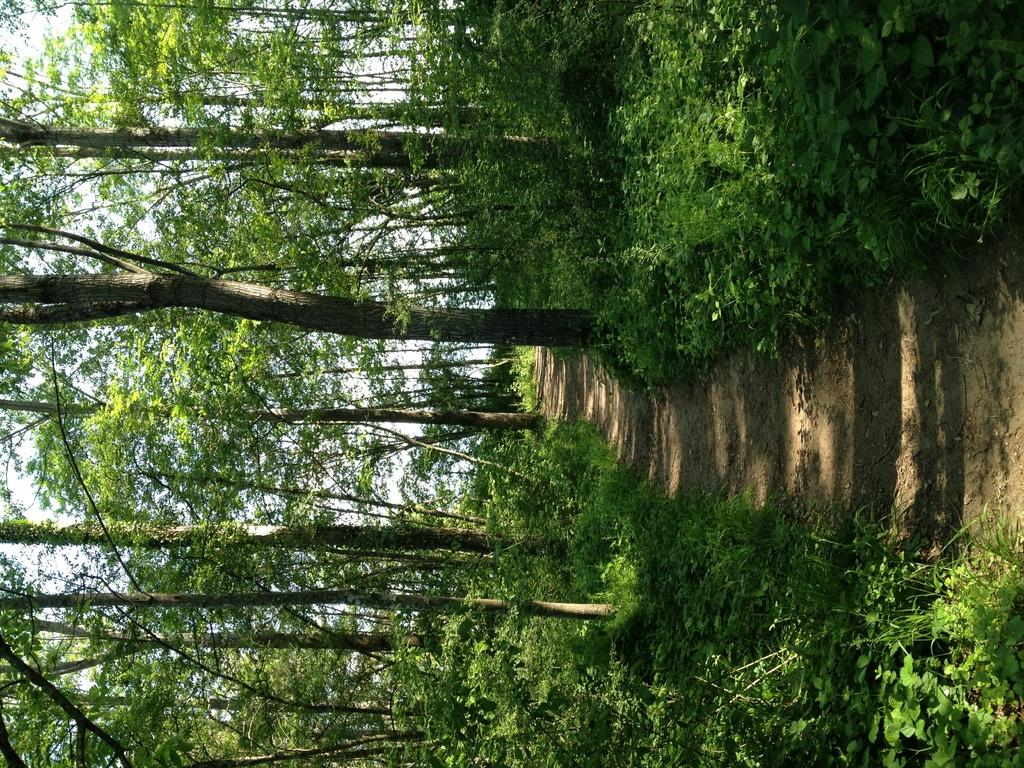In which direction is the image oriented? The image is oriented to the left. What can be seen on the right side of the image? There is a path on the right side of the image. What is present alongside the path in the image? Many plants and trees are present on both sides of the path. What is visible in the background of the image? The sky is visible in the background of the image. How many sisters are walking on the path in the image? There are no sisters present in the image; it features a path with plants and trees on both sides. What type of neck accessory is visible on the trees in the image? There are no neck accessories present on the trees in the image; it features a path with plants and trees on both sides. 